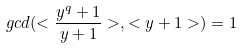Convert formula to latex. <formula><loc_0><loc_0><loc_500><loc_500>g c d ( < \frac { y ^ { q } + 1 } { y + 1 } > , < y + 1 > ) = 1</formula> 